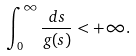<formula> <loc_0><loc_0><loc_500><loc_500>\int _ { 0 } ^ { \infty } \frac { d s } { g ( s ) } < + \infty .</formula> 